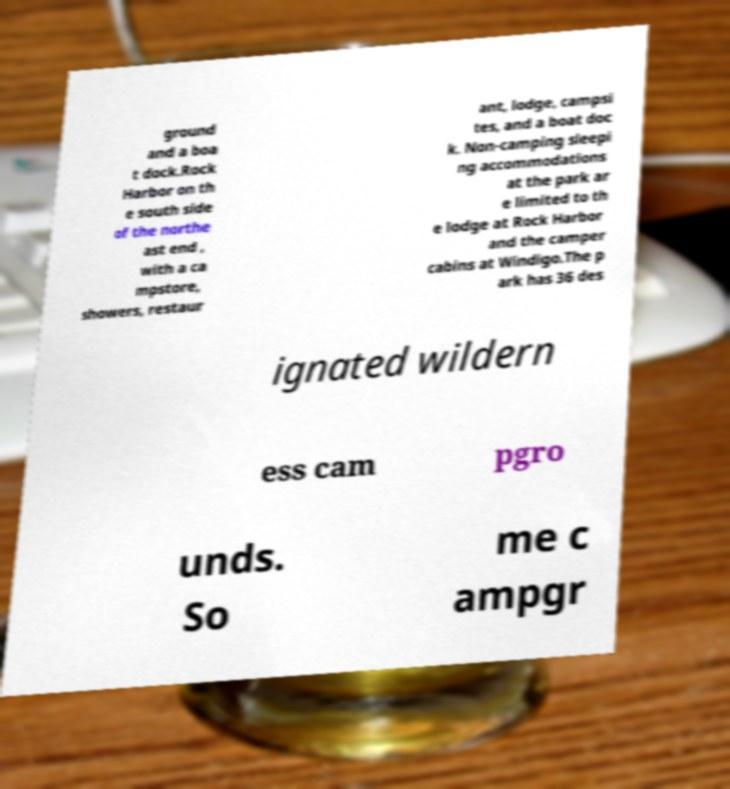Could you assist in decoding the text presented in this image and type it out clearly? ground and a boa t dock.Rock Harbor on th e south side of the northe ast end , with a ca mpstore, showers, restaur ant, lodge, campsi tes, and a boat doc k. Non-camping sleepi ng accommodations at the park ar e limited to th e lodge at Rock Harbor and the camper cabins at Windigo.The p ark has 36 des ignated wildern ess cam pgro unds. So me c ampgr 